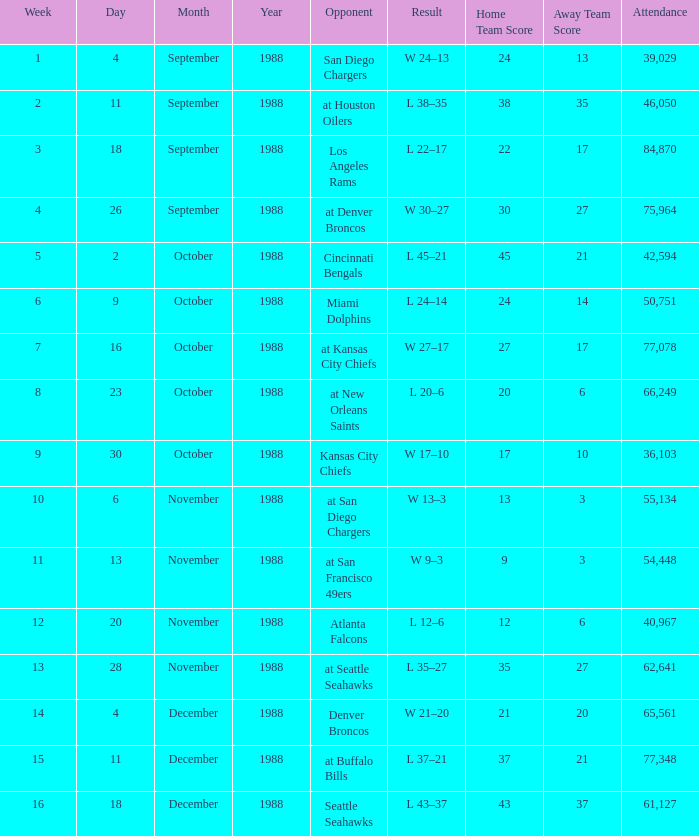What was the date during week 13? November 28, 1988. 